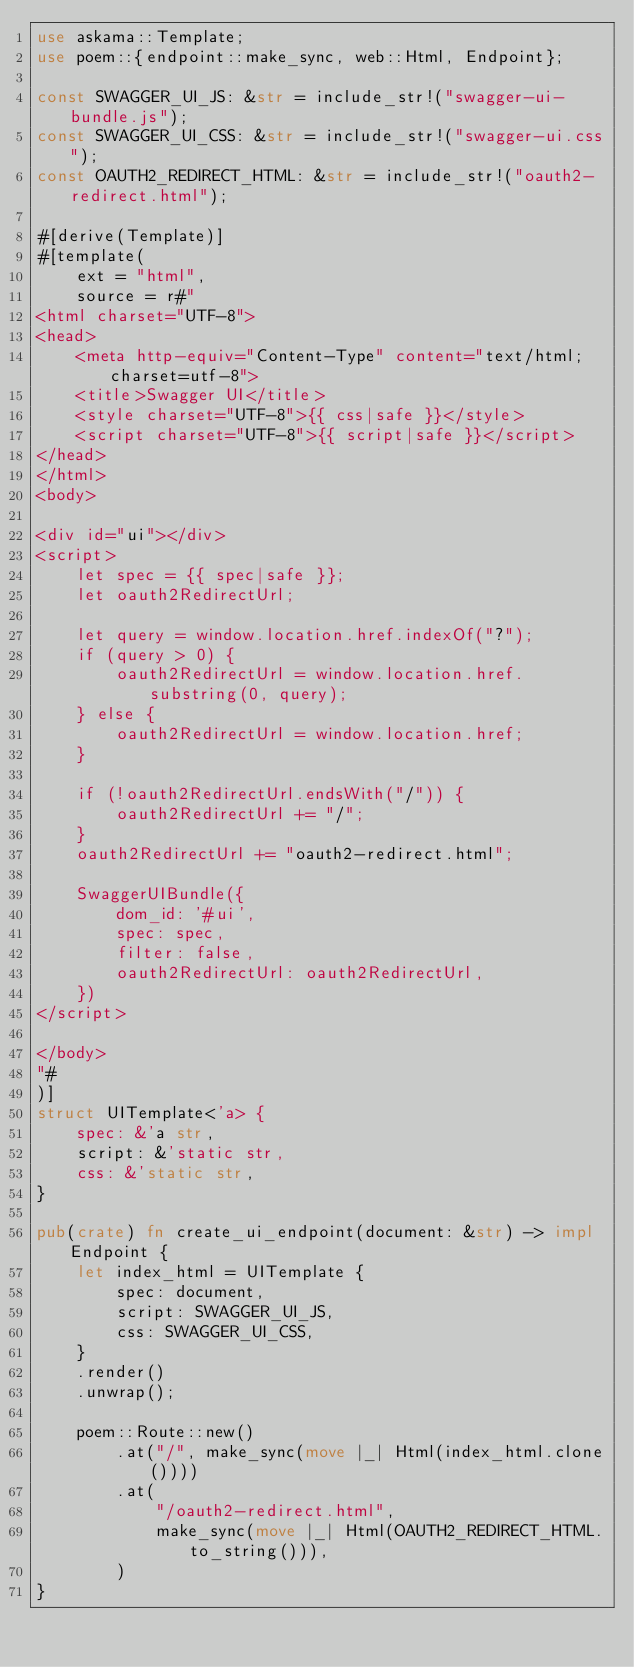<code> <loc_0><loc_0><loc_500><loc_500><_Rust_>use askama::Template;
use poem::{endpoint::make_sync, web::Html, Endpoint};

const SWAGGER_UI_JS: &str = include_str!("swagger-ui-bundle.js");
const SWAGGER_UI_CSS: &str = include_str!("swagger-ui.css");
const OAUTH2_REDIRECT_HTML: &str = include_str!("oauth2-redirect.html");

#[derive(Template)]
#[template(
    ext = "html",
    source = r#"
<html charset="UTF-8">
<head>
    <meta http-equiv="Content-Type" content="text/html;charset=utf-8">
    <title>Swagger UI</title>
    <style charset="UTF-8">{{ css|safe }}</style>
    <script charset="UTF-8">{{ script|safe }}</script>
</head>
</html>
<body>

<div id="ui"></div>
<script>
    let spec = {{ spec|safe }};
    let oauth2RedirectUrl;
    
    let query = window.location.href.indexOf("?");
    if (query > 0) {
        oauth2RedirectUrl = window.location.href.substring(0, query);
    } else {
        oauth2RedirectUrl = window.location.href;
    }
    
    if (!oauth2RedirectUrl.endsWith("/")) {
        oauth2RedirectUrl += "/";
    }
    oauth2RedirectUrl += "oauth2-redirect.html";

    SwaggerUIBundle({
        dom_id: '#ui',
        spec: spec,
        filter: false,
        oauth2RedirectUrl: oauth2RedirectUrl,
    })
</script>

</body>
"#
)]
struct UITemplate<'a> {
    spec: &'a str,
    script: &'static str,
    css: &'static str,
}

pub(crate) fn create_ui_endpoint(document: &str) -> impl Endpoint {
    let index_html = UITemplate {
        spec: document,
        script: SWAGGER_UI_JS,
        css: SWAGGER_UI_CSS,
    }
    .render()
    .unwrap();

    poem::Route::new()
        .at("/", make_sync(move |_| Html(index_html.clone())))
        .at(
            "/oauth2-redirect.html",
            make_sync(move |_| Html(OAUTH2_REDIRECT_HTML.to_string())),
        )
}
</code> 